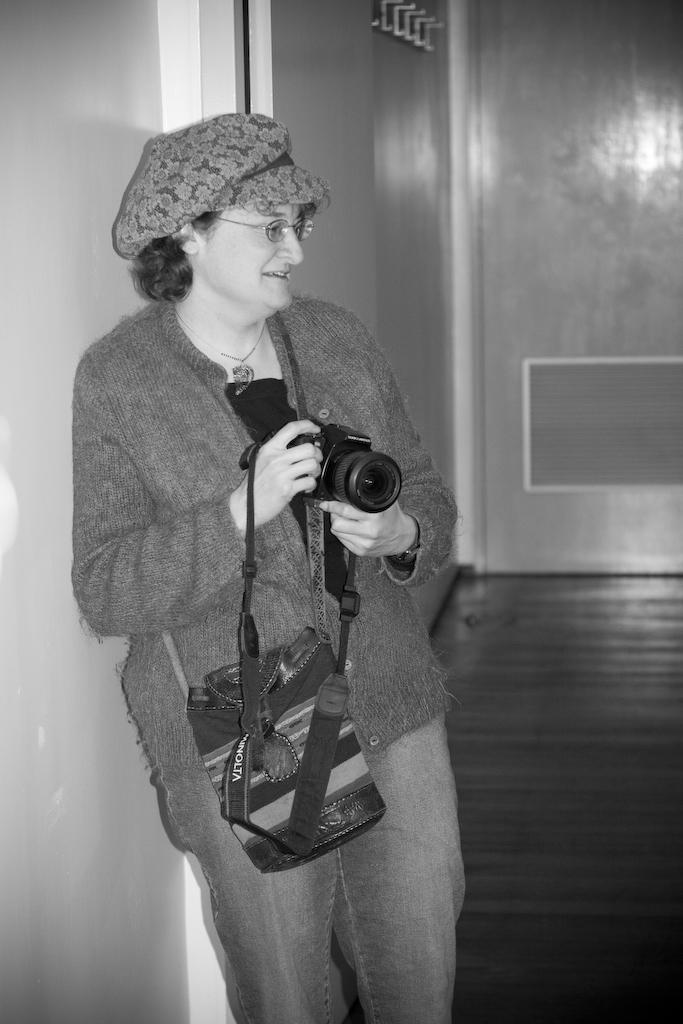What is the color scheme of the image? The image is black and white. Who is present in the image? There is a woman in the image. What accessories is the woman wearing? The woman is wearing spectacles and a cap. What is the woman holding in the image? The woman is holding a camera and a bag. What type of slope can be seen in the image? There is no slope present in the image. What is the reason for the protest in the image? There is no protest depicted in the image. 